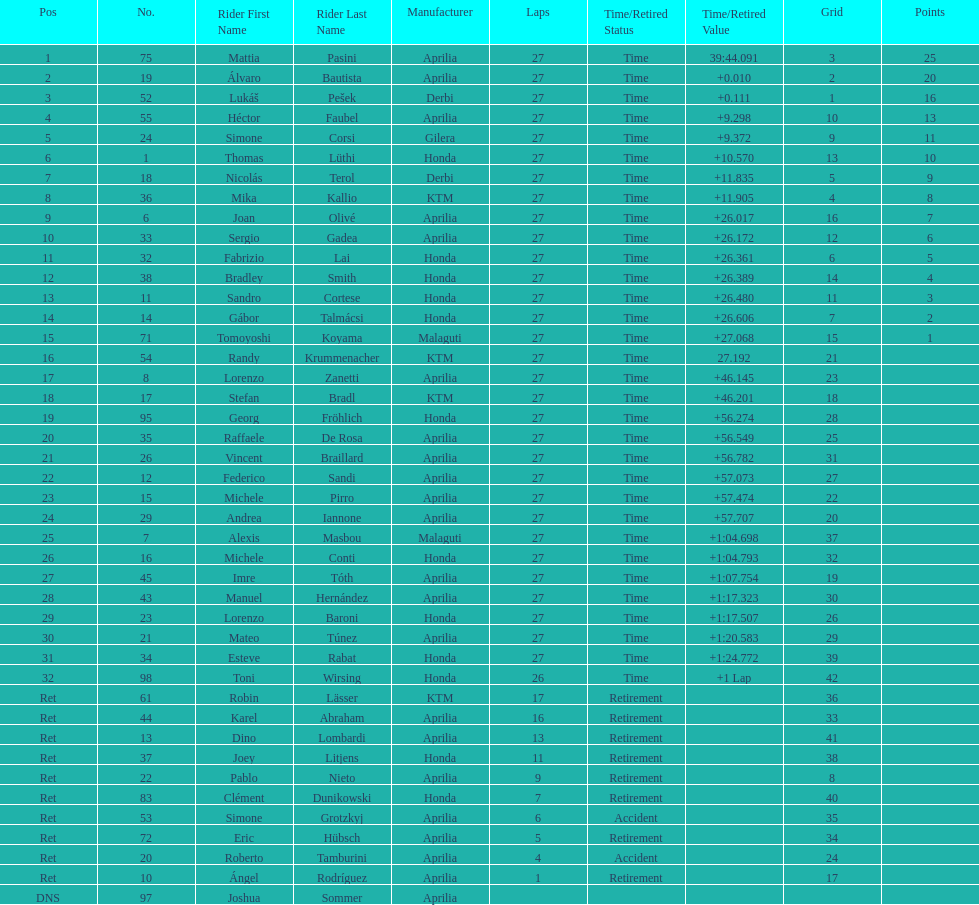How many german racers finished the race? 4. 